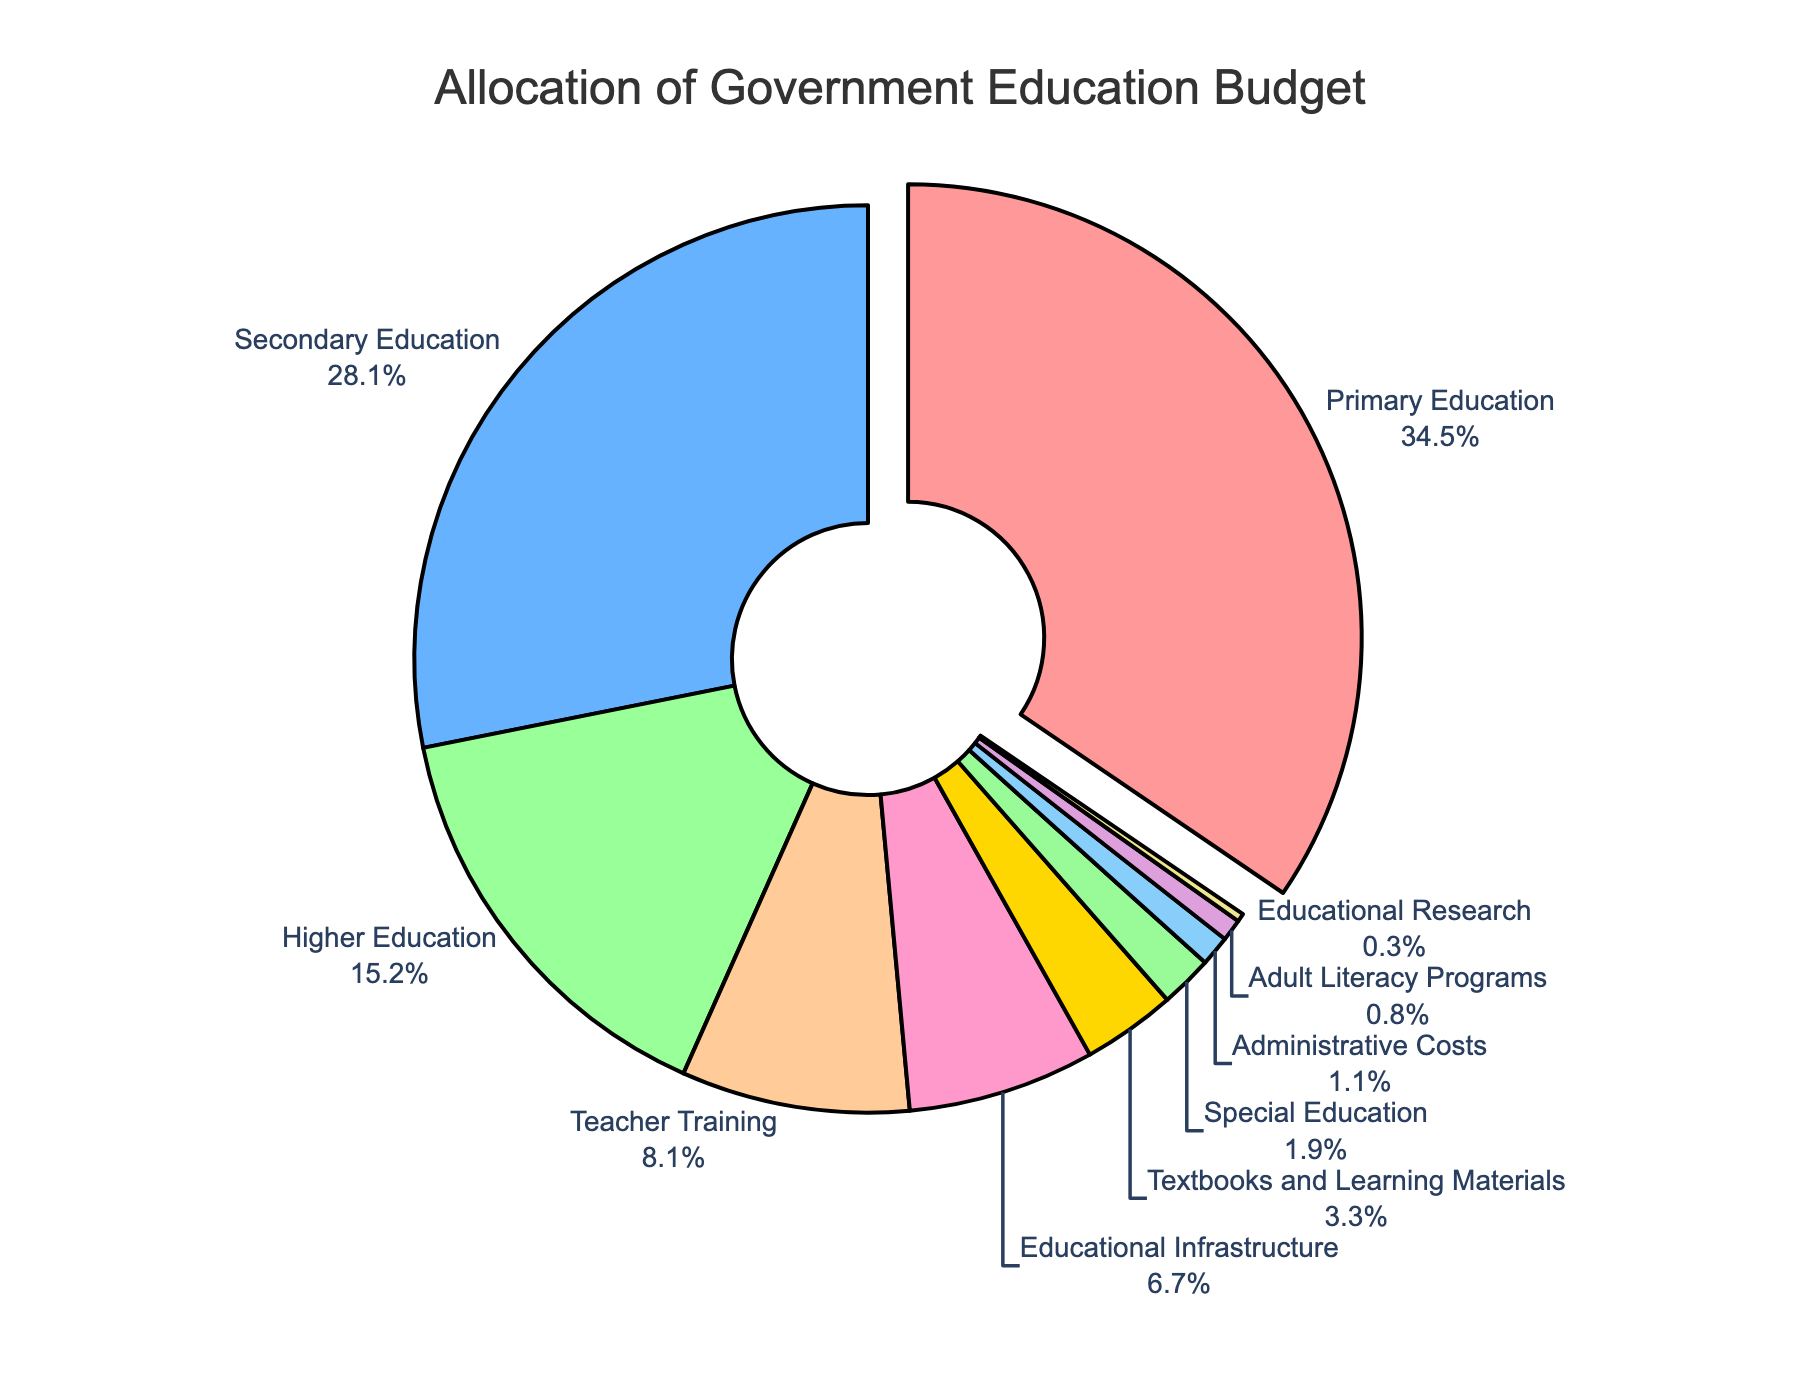Where is the largest budget allocation directed? The largest budget allocation corresponds to the segment that is pulled out slightly. This slice is Primary Education.
Answer: Primary Education What percentage of the budget is allocated to higher education and adult literacy programs combined? The percentage for Higher Education is 15.5% and for Adult Literacy Programs is 0.8%. Adding them together: 15.5% + 0.8% = 16.3%
Answer: 16.3% Which category has a larger budget allocation: Teacher Training or Educational Infrastructure? The percentages for Teacher Training and Educational Infrastructure are 8.3% and 6.8%, respectively. Comparing these, 8.3% is larger than 6.8%.
Answer: Teacher Training How much more is allocated to Secondary Education than to Special Education? The percentage for Secondary Education is 28.7% and for Special Education is 1.9%. Subtracting these gives 28.7% - 1.9% = 26.8%.
Answer: 26.8% What total percentage is allocated to categories receiving less than 5% of the budget? The categories are Textbooks and Learning Materials (3.4%), Special Education (1.9%), Adult Literacy Programs (0.8%), Educational Research (0.3%), and Administrative Costs (1.1%). Summing these: 3.4% + 1.9% + 0.8% + 0.3% + 1.1% = 7.5%.
Answer: 7.5% Which category is represented by the green color? By visually inspecting the colors, the green section corresponds to Educational Infrastructure.
Answer: Educational Infrastructure How much more is allocated to Primary Education than to Educational Research? The percentage for Primary Education is 35.2% while for Educational Research it is 0.3%. Subtracting these gives 35.2% - 0.3% = 34.9%.
Answer: 34.9% What percentage of the budget is allocated to categories that collectively receive less than 10% each? Categories include Higher Education (15.5%), Teacher Training (8.3%), Educational Infrastructure (6.8%), Textbooks and Learning Materials (3.4%), Special Education (1.9%), Adult Literacy Programs (0.8%), Educational Research (0.3%), and Administrative Costs (1.1%). Total: 8.3% + 6.8% + 3.4% + 1.9% + 0.8% + 0.3% + 1.1% = 22.6%.
Answer: 22.6% Which category slices have labels outside the pie chart, except the one with the highest allocation? By visually inspecting the chart, all categories have their labels outside the pie chart, including Secondary Education, Higher Education, Teacher Training, Educational Infrastructure, Textbooks and Learning Materials, Special Education, Adult Literacy Programs, Educational Research, and Administrative Costs.
Answer: All categories except Primary Education 